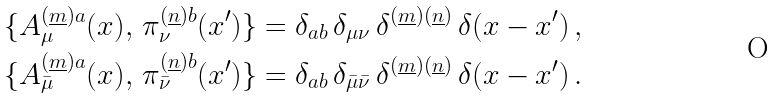<formula> <loc_0><loc_0><loc_500><loc_500>\{ A ^ { ( \underline { m } ) a } _ { \mu } ( x ) , \, \pi ^ { ( \underline { n } ) b } _ { \nu } ( x ^ { \prime } ) \} & = \delta _ { a b } \, \delta _ { \mu \nu } \, \delta ^ { ( \underline { m } ) ( \underline { n } ) } \, \delta ( x - x ^ { \prime } ) \, , \\ \{ A ^ { ( \underline { m } ) a } _ { \bar { \mu } } ( x ) , \, \pi ^ { ( \underline { n } ) b } _ { \bar { \nu } } ( x ^ { \prime } ) \} & = \delta _ { a b } \, \delta _ { \bar { \mu } \bar { \nu } } \, \delta ^ { ( \underline { m } ) ( \underline { n } ) } \, \delta ( x - x ^ { \prime } ) \, .</formula> 